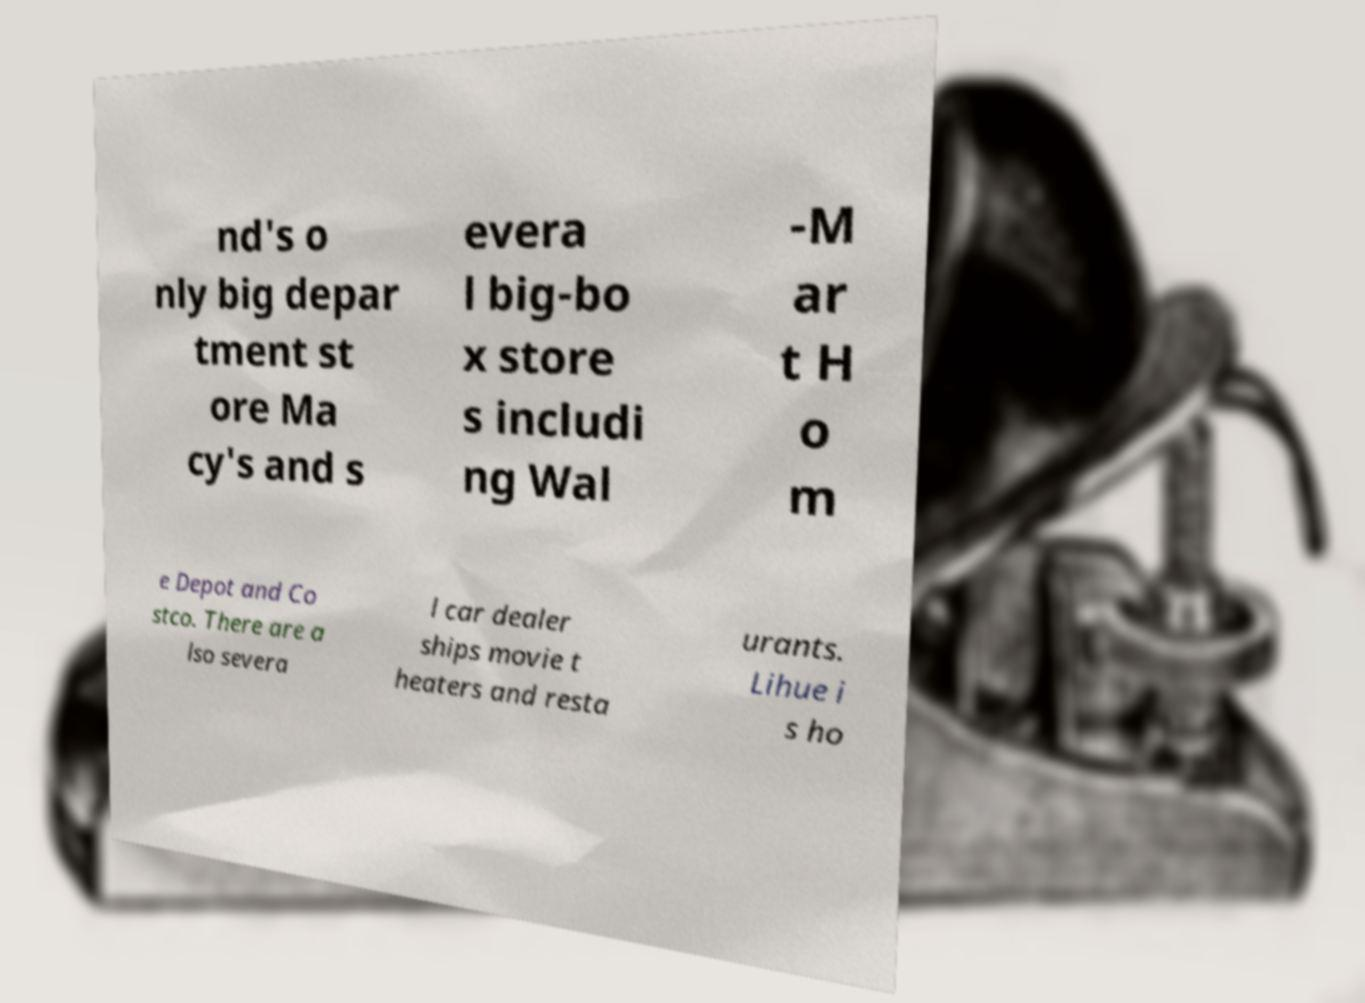There's text embedded in this image that I need extracted. Can you transcribe it verbatim? nd's o nly big depar tment st ore Ma cy's and s evera l big-bo x store s includi ng Wal -M ar t H o m e Depot and Co stco. There are a lso severa l car dealer ships movie t heaters and resta urants. Lihue i s ho 